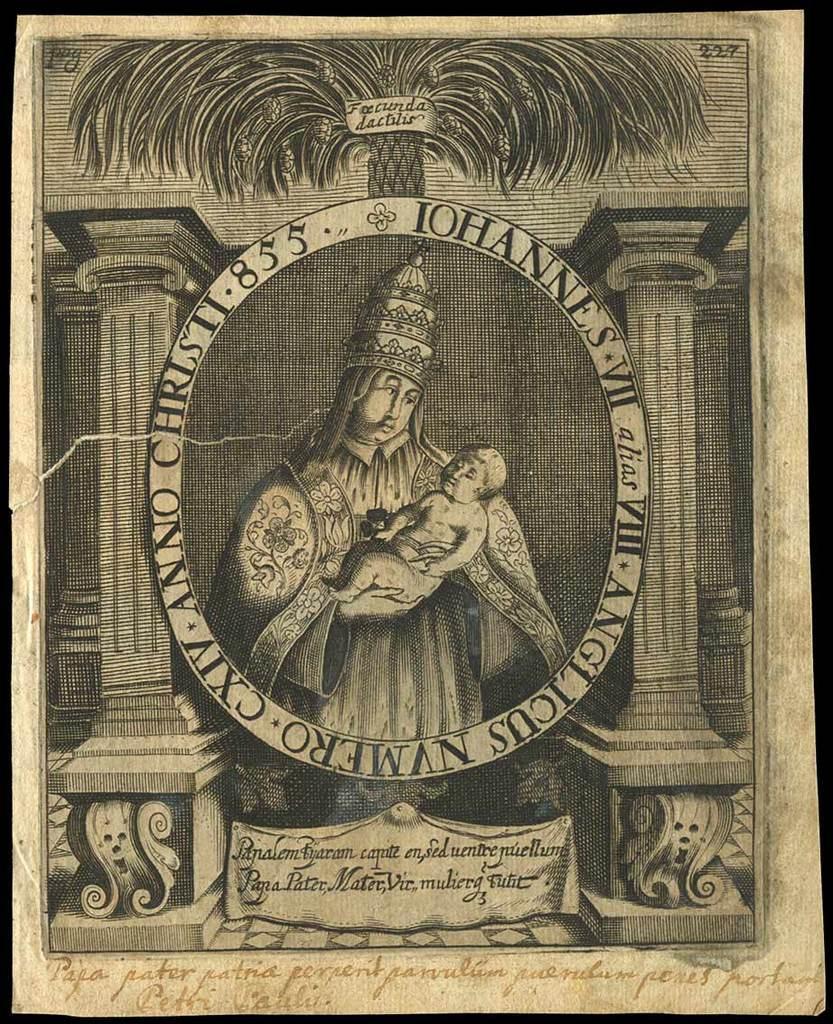Please provide a concise description of this image. In this image we can see text, person holding a baby, tree and pillars. 